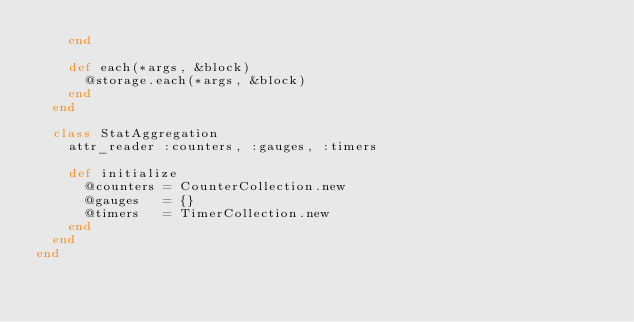<code> <loc_0><loc_0><loc_500><loc_500><_Ruby_>    end

    def each(*args, &block)
      @storage.each(*args, &block)
    end
  end

  class StatAggregation
    attr_reader :counters, :gauges, :timers

    def initialize
      @counters = CounterCollection.new
      @gauges   = {}
      @timers   = TimerCollection.new
    end
  end
end
</code> 